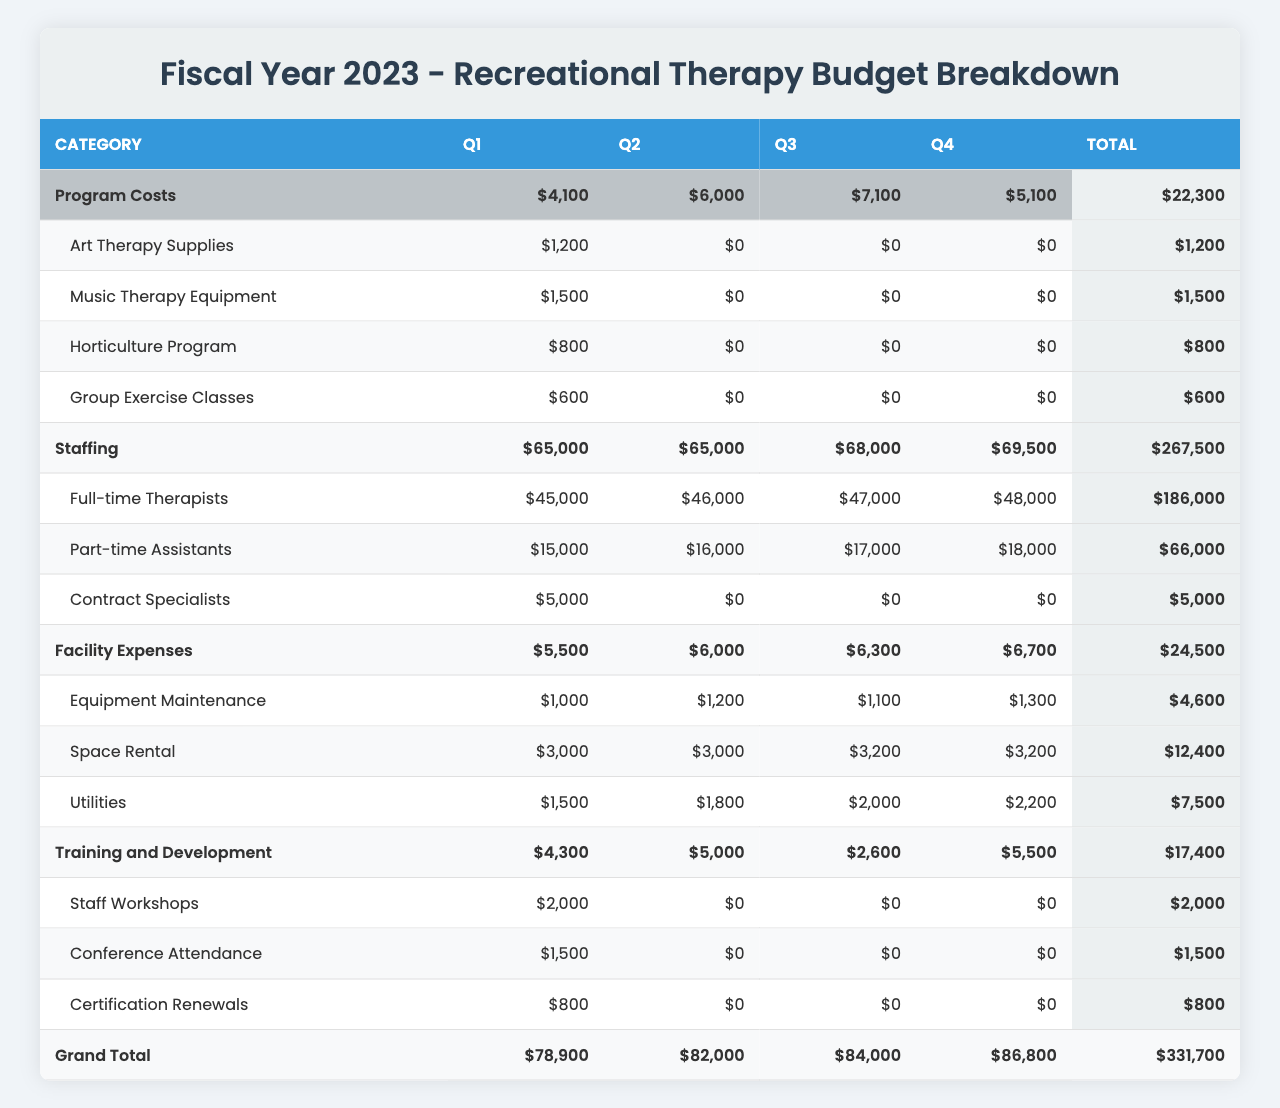What were the total Program Costs in Q3? For Q3, the Program Costs include: Aquatic Therapy Equipment ($2500), Cognitive Games and Puzzles ($900), Drama Therapy Props ($700), and Virtual Reality Systems ($3000). Summing these values gives: 2500 + 900 + 700 + 3000 = $6100.
Answer: $6100 What was the total amount spent on Staffing across all quarters? The total Staffing costs are: Q1 ($60000), Q2 ($69000), Q3 ($68000), and Q4 ($69000). Adding these amounts gives: 60000 + 69000 + 68000 + 69000 = $276000.
Answer: $276000 Did the spending on Training and Development increase in Q4 compared to Q3? In Q3, the total for Training and Development was $2600, while in Q4 it was $5500. Since $5500 is greater than $2600, the spending did increase.
Answer: Yes What is the total Facility Expenses for Q1? The Facility Expenses in Q1 include: Equipment Maintenance ($1000), Space Rental ($3000), and Utilities ($1500). Adding these amounts gives: 1000 + 3000 + 1500 = $5500.
Answer: $5500 What was the highest spending category in Q2? For Q2, the total costs across categories are: Program Costs ($7000), Staffing ($65000), Facility Expenses ($6000), and Training and Development ($5000). The highest value is in Staffing, which is $65000.
Answer: Staffing How much more was spent on Full-time Therapists in Q4 compared to Q1? In Q4, the spending on Full-time Therapists was $48000, and in Q1 it was $45000. The difference is calculated as: 48000 - 45000 = $3000.
Answer: $3000 Calculate the average amount spent on utilities per quarter. The utilities spending per quarter is: Q1 ($1500), Q2 ($1800), Q3 ($2000), and Q4 ($2200). The average is calculated as: (1500 + 1800 + 2000 + 2200) / 4 = 1875.
Answer: $1875 Which quarter had the highest spending on Art Therapy Supplies? Art Therapy Supplies only appear in Q1, where $1200 was spent. Thus, no other quarter can exceed this amount.
Answer: Q1 What was the total expenditure on Training and Development for the whole year? The total expenditures are: Q1 ($4300), Q2 ($5000), Q3 ($2600), and Q4 ($5500). Summing these gives: 4300 + 5000 + 2600 + 5500 = $17400.
Answer: $17400 Was the combined spending on Program Costs for the year greater than $25000? To check this, sum Program Costs from all quarters: Q1 ($4100), Q2 ($5700), Q3 ($4900), and Q4 ($4100). The total is 4100 + 5700 + 4900 + 4100 = $18800, which is less than $25000.
Answer: No 